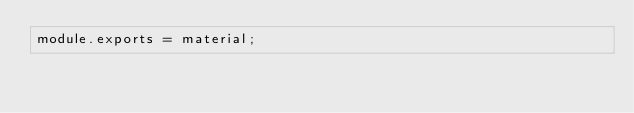Convert code to text. <code><loc_0><loc_0><loc_500><loc_500><_JavaScript_>module.exports = material;</code> 